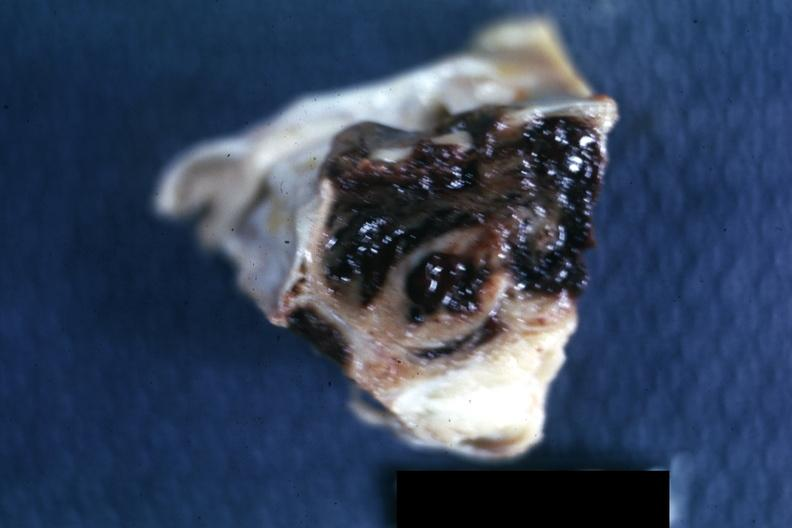s lateral view present?
Answer the question using a single word or phrase. No 